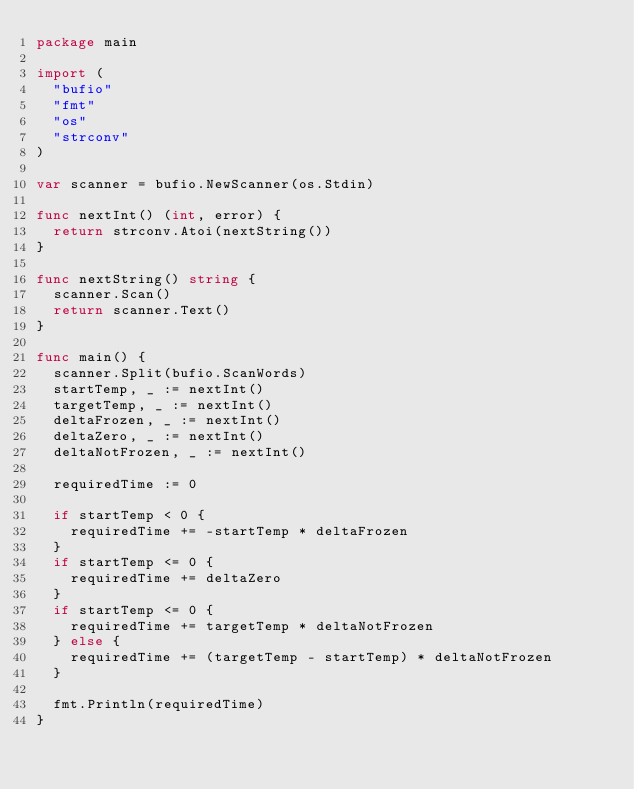<code> <loc_0><loc_0><loc_500><loc_500><_Go_>package main

import (
	"bufio"
	"fmt"
	"os"
	"strconv"
)

var scanner = bufio.NewScanner(os.Stdin)

func nextInt() (int, error) {
	return strconv.Atoi(nextString())
}

func nextString() string {
	scanner.Scan()
	return scanner.Text()
}

func main() {
	scanner.Split(bufio.ScanWords)
	startTemp, _ := nextInt()
	targetTemp, _ := nextInt()
	deltaFrozen, _ := nextInt()
	deltaZero, _ := nextInt()
	deltaNotFrozen, _ := nextInt()

	requiredTime := 0

	if startTemp < 0 {
		requiredTime += -startTemp * deltaFrozen
	}
	if startTemp <= 0 {
		requiredTime += deltaZero
	}
	if startTemp <= 0 {
		requiredTime += targetTemp * deltaNotFrozen
	} else {
		requiredTime += (targetTemp - startTemp) * deltaNotFrozen
	}

	fmt.Println(requiredTime)
}

</code> 